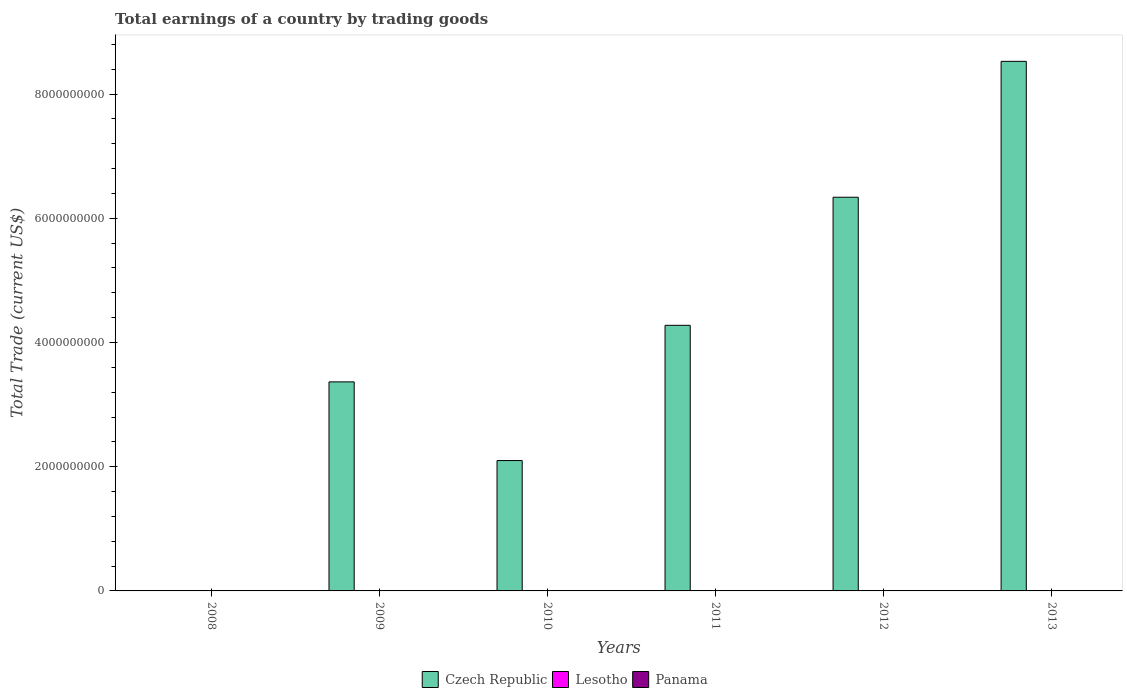Are the number of bars per tick equal to the number of legend labels?
Offer a very short reply. No. How many bars are there on the 2nd tick from the left?
Offer a very short reply. 1. What is the label of the 4th group of bars from the left?
Offer a very short reply. 2011. In how many cases, is the number of bars for a given year not equal to the number of legend labels?
Your response must be concise. 6. Across all years, what is the maximum total earnings in Czech Republic?
Offer a terse response. 8.53e+09. What is the total total earnings in Panama in the graph?
Offer a terse response. 0. What is the difference between the total earnings in Czech Republic in 2010 and that in 2012?
Your answer should be very brief. -4.24e+09. What is the difference between the total earnings in Lesotho in 2008 and the total earnings in Czech Republic in 2009?
Offer a very short reply. -3.37e+09. What is the average total earnings in Lesotho per year?
Give a very brief answer. 0. In how many years, is the total earnings in Panama greater than 6800000000 US$?
Give a very brief answer. 0. What is the ratio of the total earnings in Czech Republic in 2012 to that in 2013?
Ensure brevity in your answer.  0.74. Is the total earnings in Czech Republic in 2012 less than that in 2013?
Your answer should be very brief. Yes. What is the difference between the highest and the second highest total earnings in Czech Republic?
Give a very brief answer. 2.19e+09. What is the difference between the highest and the lowest total earnings in Czech Republic?
Ensure brevity in your answer.  8.53e+09. Is it the case that in every year, the sum of the total earnings in Lesotho and total earnings in Czech Republic is greater than the total earnings in Panama?
Ensure brevity in your answer.  No. Are all the bars in the graph horizontal?
Provide a short and direct response. No. What is the difference between two consecutive major ticks on the Y-axis?
Your response must be concise. 2.00e+09. Are the values on the major ticks of Y-axis written in scientific E-notation?
Your response must be concise. No. Does the graph contain any zero values?
Ensure brevity in your answer.  Yes. Does the graph contain grids?
Give a very brief answer. No. How many legend labels are there?
Provide a succinct answer. 3. How are the legend labels stacked?
Make the answer very short. Horizontal. What is the title of the graph?
Make the answer very short. Total earnings of a country by trading goods. What is the label or title of the Y-axis?
Make the answer very short. Total Trade (current US$). What is the Total Trade (current US$) in Czech Republic in 2008?
Provide a short and direct response. 0. What is the Total Trade (current US$) of Czech Republic in 2009?
Ensure brevity in your answer.  3.37e+09. What is the Total Trade (current US$) in Lesotho in 2009?
Keep it short and to the point. 0. What is the Total Trade (current US$) in Czech Republic in 2010?
Give a very brief answer. 2.10e+09. What is the Total Trade (current US$) in Lesotho in 2010?
Your answer should be compact. 0. What is the Total Trade (current US$) in Panama in 2010?
Keep it short and to the point. 0. What is the Total Trade (current US$) in Czech Republic in 2011?
Ensure brevity in your answer.  4.28e+09. What is the Total Trade (current US$) of Czech Republic in 2012?
Ensure brevity in your answer.  6.34e+09. What is the Total Trade (current US$) of Czech Republic in 2013?
Ensure brevity in your answer.  8.53e+09. What is the Total Trade (current US$) in Lesotho in 2013?
Your answer should be compact. 0. What is the Total Trade (current US$) of Panama in 2013?
Provide a short and direct response. 0. Across all years, what is the maximum Total Trade (current US$) of Czech Republic?
Your answer should be compact. 8.53e+09. What is the total Total Trade (current US$) in Czech Republic in the graph?
Your response must be concise. 2.46e+1. What is the difference between the Total Trade (current US$) in Czech Republic in 2009 and that in 2010?
Your answer should be very brief. 1.27e+09. What is the difference between the Total Trade (current US$) in Czech Republic in 2009 and that in 2011?
Give a very brief answer. -9.11e+08. What is the difference between the Total Trade (current US$) of Czech Republic in 2009 and that in 2012?
Ensure brevity in your answer.  -2.97e+09. What is the difference between the Total Trade (current US$) in Czech Republic in 2009 and that in 2013?
Give a very brief answer. -5.16e+09. What is the difference between the Total Trade (current US$) of Czech Republic in 2010 and that in 2011?
Ensure brevity in your answer.  -2.18e+09. What is the difference between the Total Trade (current US$) of Czech Republic in 2010 and that in 2012?
Provide a succinct answer. -4.24e+09. What is the difference between the Total Trade (current US$) of Czech Republic in 2010 and that in 2013?
Your answer should be very brief. -6.43e+09. What is the difference between the Total Trade (current US$) in Czech Republic in 2011 and that in 2012?
Keep it short and to the point. -2.06e+09. What is the difference between the Total Trade (current US$) in Czech Republic in 2011 and that in 2013?
Ensure brevity in your answer.  -4.25e+09. What is the difference between the Total Trade (current US$) of Czech Republic in 2012 and that in 2013?
Your response must be concise. -2.19e+09. What is the average Total Trade (current US$) in Czech Republic per year?
Your answer should be very brief. 4.10e+09. What is the average Total Trade (current US$) of Lesotho per year?
Provide a short and direct response. 0. What is the ratio of the Total Trade (current US$) of Czech Republic in 2009 to that in 2010?
Give a very brief answer. 1.6. What is the ratio of the Total Trade (current US$) in Czech Republic in 2009 to that in 2011?
Offer a very short reply. 0.79. What is the ratio of the Total Trade (current US$) in Czech Republic in 2009 to that in 2012?
Your response must be concise. 0.53. What is the ratio of the Total Trade (current US$) of Czech Republic in 2009 to that in 2013?
Offer a very short reply. 0.39. What is the ratio of the Total Trade (current US$) in Czech Republic in 2010 to that in 2011?
Your response must be concise. 0.49. What is the ratio of the Total Trade (current US$) in Czech Republic in 2010 to that in 2012?
Keep it short and to the point. 0.33. What is the ratio of the Total Trade (current US$) in Czech Republic in 2010 to that in 2013?
Your answer should be very brief. 0.25. What is the ratio of the Total Trade (current US$) of Czech Republic in 2011 to that in 2012?
Provide a short and direct response. 0.67. What is the ratio of the Total Trade (current US$) of Czech Republic in 2011 to that in 2013?
Your answer should be very brief. 0.5. What is the ratio of the Total Trade (current US$) of Czech Republic in 2012 to that in 2013?
Provide a short and direct response. 0.74. What is the difference between the highest and the second highest Total Trade (current US$) of Czech Republic?
Provide a succinct answer. 2.19e+09. What is the difference between the highest and the lowest Total Trade (current US$) of Czech Republic?
Offer a terse response. 8.53e+09. 